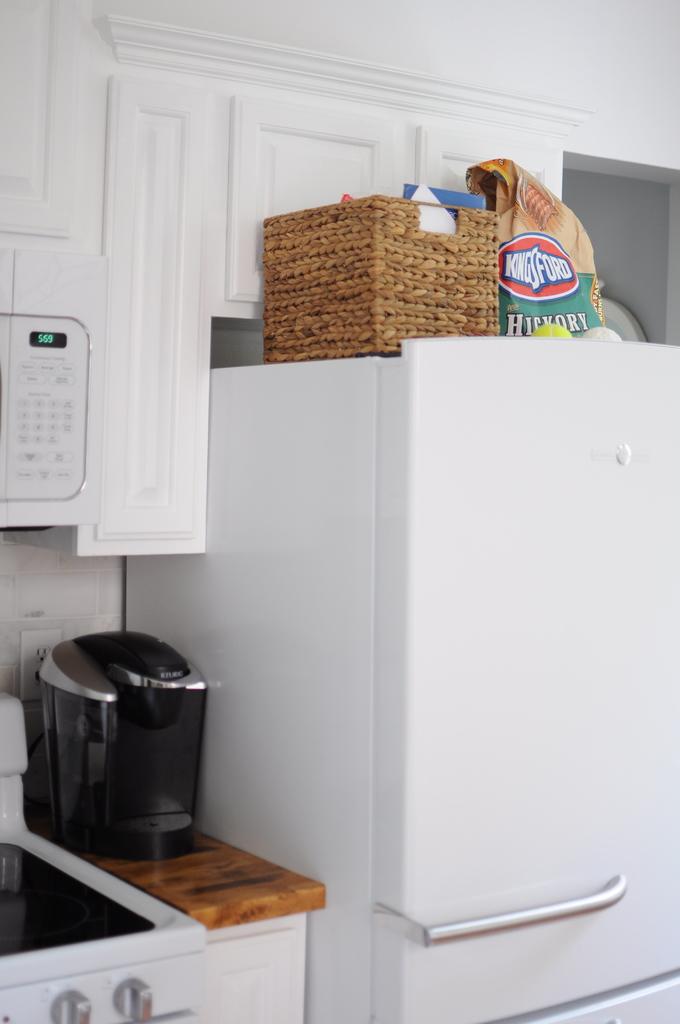What flavory of charcoal?
Provide a short and direct response. Hickory. What brand is the charcoal?
Your answer should be very brief. Kingsford. 